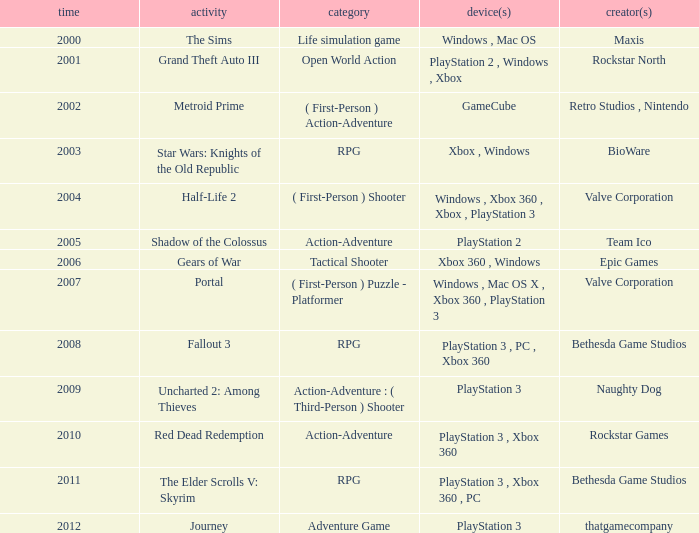What game was in 2005? Shadow of the Colossus. 